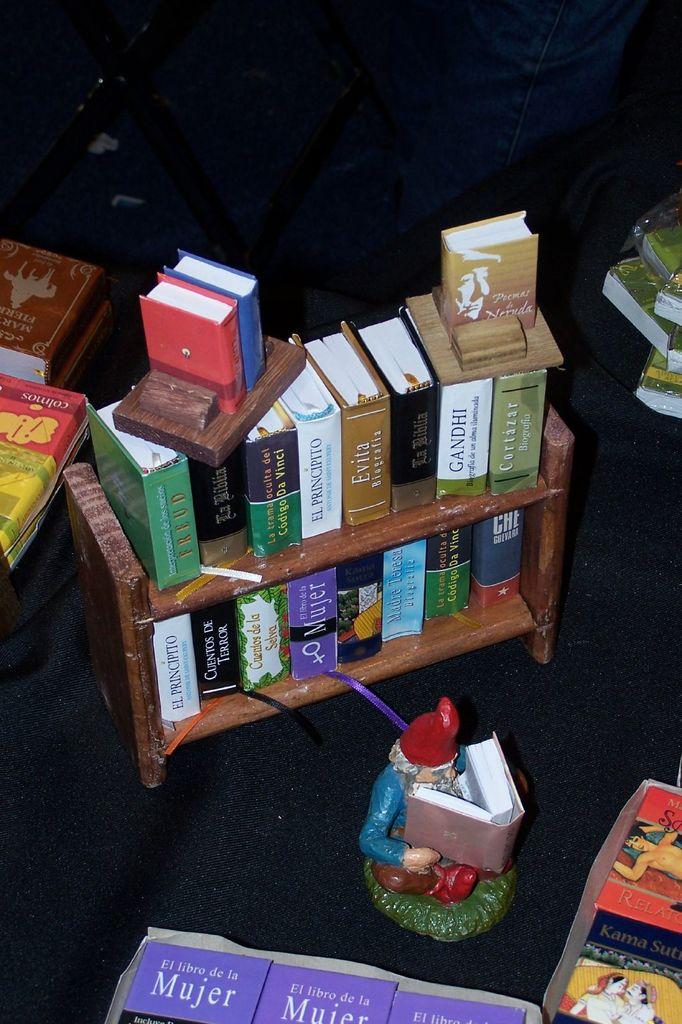What is the title of the purple book in the bottom?
Your answer should be compact. Mujer. Who is the top book on the right baout?
Your response must be concise. Neruda. 